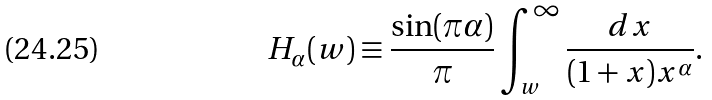<formula> <loc_0><loc_0><loc_500><loc_500>H _ { \alpha } ( w ) \equiv \frac { \sin ( \pi \alpha ) } { \pi } \int _ { w } ^ { \infty } \frac { d x } { ( 1 + x ) x ^ { \alpha } } .</formula> 